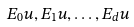<formula> <loc_0><loc_0><loc_500><loc_500>E _ { 0 } u , E _ { 1 } u , \dots , E _ { d } u</formula> 